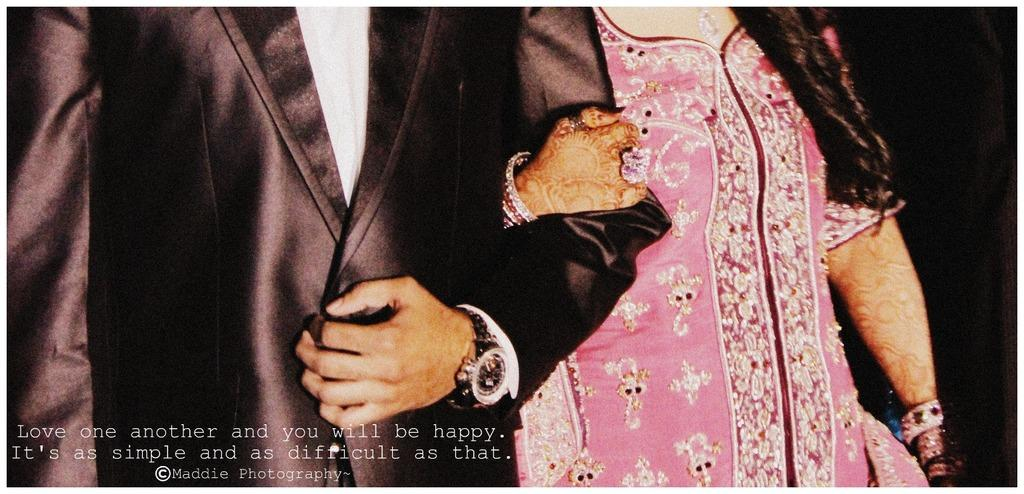How many people are in the image? There are two people in the image, a man and a woman. What are the man and woman doing in the image? The man and woman are standing together. What is the man wearing in the image? The man is wearing a suit and a watch. What is the woman wearing in the image? The woman is wearing a pink dress. How many roses can be seen in the image? There are no roses present in the image. What process is being carried out by the man and woman in the image? The image does not depict a specific process; it simply shows a man and a woman standing together. 